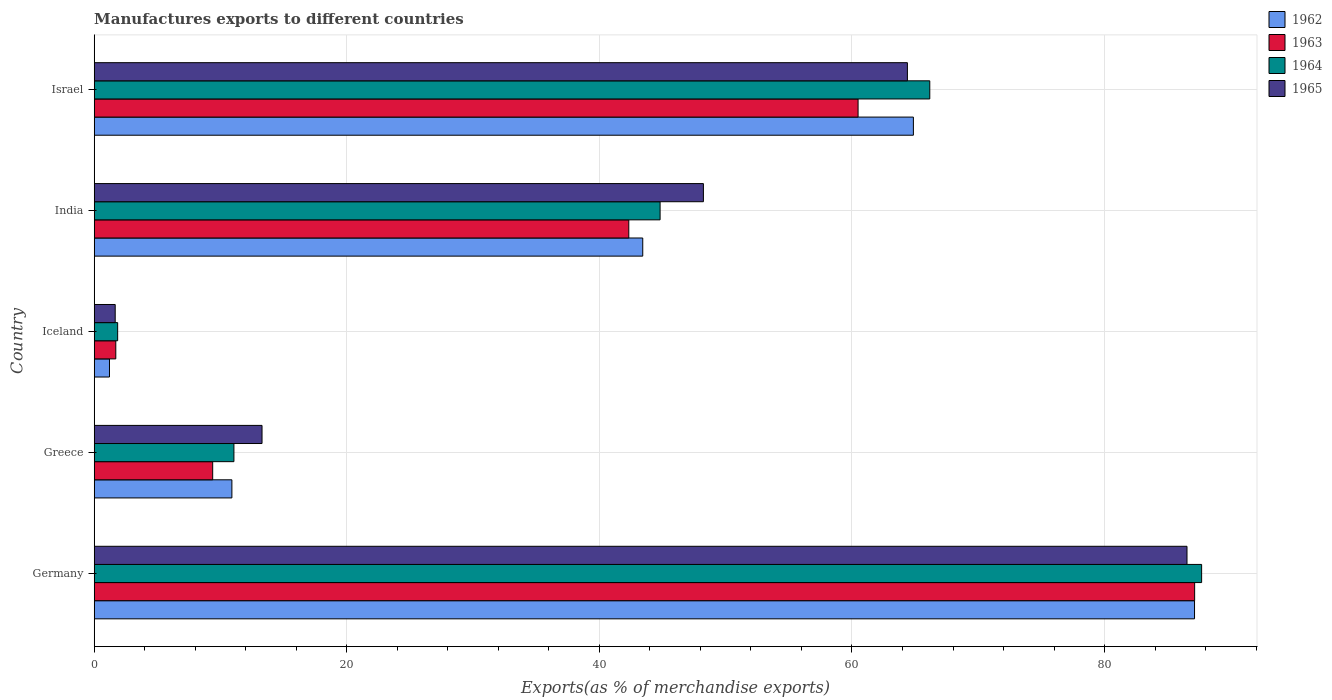How many bars are there on the 4th tick from the top?
Make the answer very short. 4. What is the label of the 4th group of bars from the top?
Your response must be concise. Greece. What is the percentage of exports to different countries in 1962 in Germany?
Your response must be concise. 87.12. Across all countries, what is the maximum percentage of exports to different countries in 1963?
Your answer should be very brief. 87.13. Across all countries, what is the minimum percentage of exports to different countries in 1962?
Give a very brief answer. 1.21. In which country was the percentage of exports to different countries in 1964 maximum?
Your answer should be compact. Germany. What is the total percentage of exports to different countries in 1962 in the graph?
Provide a short and direct response. 207.53. What is the difference between the percentage of exports to different countries in 1965 in Germany and that in Israel?
Keep it short and to the point. 22.14. What is the difference between the percentage of exports to different countries in 1965 in India and the percentage of exports to different countries in 1962 in Germany?
Provide a succinct answer. -38.89. What is the average percentage of exports to different countries in 1964 per country?
Offer a very short reply. 42.31. What is the difference between the percentage of exports to different countries in 1965 and percentage of exports to different countries in 1964 in India?
Keep it short and to the point. 3.43. In how many countries, is the percentage of exports to different countries in 1963 greater than 68 %?
Give a very brief answer. 1. What is the ratio of the percentage of exports to different countries in 1963 in Greece to that in Israel?
Your answer should be compact. 0.16. Is the difference between the percentage of exports to different countries in 1965 in Germany and Greece greater than the difference between the percentage of exports to different countries in 1964 in Germany and Greece?
Give a very brief answer. No. What is the difference between the highest and the second highest percentage of exports to different countries in 1965?
Your response must be concise. 22.14. What is the difference between the highest and the lowest percentage of exports to different countries in 1964?
Your answer should be compact. 85.83. In how many countries, is the percentage of exports to different countries in 1963 greater than the average percentage of exports to different countries in 1963 taken over all countries?
Your response must be concise. 3. What does the 2nd bar from the top in India represents?
Provide a succinct answer. 1964. Are all the bars in the graph horizontal?
Give a very brief answer. Yes. What is the difference between two consecutive major ticks on the X-axis?
Provide a short and direct response. 20. Does the graph contain grids?
Offer a terse response. Yes. How are the legend labels stacked?
Give a very brief answer. Vertical. What is the title of the graph?
Provide a succinct answer. Manufactures exports to different countries. What is the label or title of the X-axis?
Offer a very short reply. Exports(as % of merchandise exports). What is the label or title of the Y-axis?
Your answer should be compact. Country. What is the Exports(as % of merchandise exports) in 1962 in Germany?
Your response must be concise. 87.12. What is the Exports(as % of merchandise exports) of 1963 in Germany?
Your answer should be compact. 87.13. What is the Exports(as % of merchandise exports) in 1964 in Germany?
Your response must be concise. 87.69. What is the Exports(as % of merchandise exports) in 1965 in Germany?
Your answer should be compact. 86.53. What is the Exports(as % of merchandise exports) in 1962 in Greece?
Your response must be concise. 10.9. What is the Exports(as % of merchandise exports) of 1963 in Greece?
Provide a succinct answer. 9.38. What is the Exports(as % of merchandise exports) in 1964 in Greece?
Make the answer very short. 11.06. What is the Exports(as % of merchandise exports) of 1965 in Greece?
Make the answer very short. 13.29. What is the Exports(as % of merchandise exports) of 1962 in Iceland?
Offer a very short reply. 1.21. What is the Exports(as % of merchandise exports) in 1963 in Iceland?
Offer a terse response. 1.71. What is the Exports(as % of merchandise exports) in 1964 in Iceland?
Make the answer very short. 1.86. What is the Exports(as % of merchandise exports) in 1965 in Iceland?
Your response must be concise. 1.66. What is the Exports(as % of merchandise exports) of 1962 in India?
Your response must be concise. 43.43. What is the Exports(as % of merchandise exports) of 1963 in India?
Provide a short and direct response. 42.33. What is the Exports(as % of merchandise exports) of 1964 in India?
Provide a short and direct response. 44.81. What is the Exports(as % of merchandise exports) in 1965 in India?
Offer a terse response. 48.24. What is the Exports(as % of merchandise exports) of 1962 in Israel?
Offer a very short reply. 64.86. What is the Exports(as % of merchandise exports) of 1963 in Israel?
Your response must be concise. 60.48. What is the Exports(as % of merchandise exports) of 1964 in Israel?
Make the answer very short. 66.16. What is the Exports(as % of merchandise exports) of 1965 in Israel?
Keep it short and to the point. 64.39. Across all countries, what is the maximum Exports(as % of merchandise exports) of 1962?
Your answer should be very brief. 87.12. Across all countries, what is the maximum Exports(as % of merchandise exports) of 1963?
Offer a terse response. 87.13. Across all countries, what is the maximum Exports(as % of merchandise exports) in 1964?
Your response must be concise. 87.69. Across all countries, what is the maximum Exports(as % of merchandise exports) of 1965?
Your answer should be very brief. 86.53. Across all countries, what is the minimum Exports(as % of merchandise exports) of 1962?
Offer a terse response. 1.21. Across all countries, what is the minimum Exports(as % of merchandise exports) of 1963?
Offer a terse response. 1.71. Across all countries, what is the minimum Exports(as % of merchandise exports) of 1964?
Provide a short and direct response. 1.86. Across all countries, what is the minimum Exports(as % of merchandise exports) in 1965?
Your answer should be very brief. 1.66. What is the total Exports(as % of merchandise exports) of 1962 in the graph?
Ensure brevity in your answer.  207.53. What is the total Exports(as % of merchandise exports) in 1963 in the graph?
Your answer should be very brief. 201.04. What is the total Exports(as % of merchandise exports) in 1964 in the graph?
Keep it short and to the point. 211.57. What is the total Exports(as % of merchandise exports) of 1965 in the graph?
Provide a succinct answer. 214.11. What is the difference between the Exports(as % of merchandise exports) of 1962 in Germany and that in Greece?
Keep it short and to the point. 76.22. What is the difference between the Exports(as % of merchandise exports) of 1963 in Germany and that in Greece?
Offer a very short reply. 77.75. What is the difference between the Exports(as % of merchandise exports) in 1964 in Germany and that in Greece?
Your response must be concise. 76.62. What is the difference between the Exports(as % of merchandise exports) of 1965 in Germany and that in Greece?
Offer a very short reply. 73.24. What is the difference between the Exports(as % of merchandise exports) of 1962 in Germany and that in Iceland?
Provide a short and direct response. 85.91. What is the difference between the Exports(as % of merchandise exports) of 1963 in Germany and that in Iceland?
Make the answer very short. 85.42. What is the difference between the Exports(as % of merchandise exports) of 1964 in Germany and that in Iceland?
Your response must be concise. 85.83. What is the difference between the Exports(as % of merchandise exports) in 1965 in Germany and that in Iceland?
Make the answer very short. 84.86. What is the difference between the Exports(as % of merchandise exports) in 1962 in Germany and that in India?
Keep it short and to the point. 43.69. What is the difference between the Exports(as % of merchandise exports) in 1963 in Germany and that in India?
Offer a very short reply. 44.8. What is the difference between the Exports(as % of merchandise exports) in 1964 in Germany and that in India?
Offer a terse response. 42.88. What is the difference between the Exports(as % of merchandise exports) in 1965 in Germany and that in India?
Provide a short and direct response. 38.29. What is the difference between the Exports(as % of merchandise exports) of 1962 in Germany and that in Israel?
Provide a short and direct response. 22.26. What is the difference between the Exports(as % of merchandise exports) in 1963 in Germany and that in Israel?
Offer a very short reply. 26.65. What is the difference between the Exports(as % of merchandise exports) in 1964 in Germany and that in Israel?
Provide a short and direct response. 21.52. What is the difference between the Exports(as % of merchandise exports) of 1965 in Germany and that in Israel?
Ensure brevity in your answer.  22.14. What is the difference between the Exports(as % of merchandise exports) in 1962 in Greece and that in Iceland?
Offer a terse response. 9.69. What is the difference between the Exports(as % of merchandise exports) in 1963 in Greece and that in Iceland?
Offer a terse response. 7.67. What is the difference between the Exports(as % of merchandise exports) of 1964 in Greece and that in Iceland?
Your response must be concise. 9.21. What is the difference between the Exports(as % of merchandise exports) of 1965 in Greece and that in Iceland?
Offer a very short reply. 11.63. What is the difference between the Exports(as % of merchandise exports) in 1962 in Greece and that in India?
Offer a terse response. -32.53. What is the difference between the Exports(as % of merchandise exports) in 1963 in Greece and that in India?
Provide a succinct answer. -32.95. What is the difference between the Exports(as % of merchandise exports) in 1964 in Greece and that in India?
Provide a succinct answer. -33.74. What is the difference between the Exports(as % of merchandise exports) in 1965 in Greece and that in India?
Give a very brief answer. -34.95. What is the difference between the Exports(as % of merchandise exports) of 1962 in Greece and that in Israel?
Provide a short and direct response. -53.96. What is the difference between the Exports(as % of merchandise exports) of 1963 in Greece and that in Israel?
Offer a terse response. -51.1. What is the difference between the Exports(as % of merchandise exports) in 1964 in Greece and that in Israel?
Your answer should be compact. -55.1. What is the difference between the Exports(as % of merchandise exports) in 1965 in Greece and that in Israel?
Make the answer very short. -51.1. What is the difference between the Exports(as % of merchandise exports) of 1962 in Iceland and that in India?
Keep it short and to the point. -42.22. What is the difference between the Exports(as % of merchandise exports) in 1963 in Iceland and that in India?
Offer a terse response. -40.62. What is the difference between the Exports(as % of merchandise exports) of 1964 in Iceland and that in India?
Provide a succinct answer. -42.95. What is the difference between the Exports(as % of merchandise exports) in 1965 in Iceland and that in India?
Give a very brief answer. -46.57. What is the difference between the Exports(as % of merchandise exports) of 1962 in Iceland and that in Israel?
Offer a very short reply. -63.65. What is the difference between the Exports(as % of merchandise exports) in 1963 in Iceland and that in Israel?
Keep it short and to the point. -58.77. What is the difference between the Exports(as % of merchandise exports) of 1964 in Iceland and that in Israel?
Your answer should be very brief. -64.3. What is the difference between the Exports(as % of merchandise exports) in 1965 in Iceland and that in Israel?
Offer a very short reply. -62.73. What is the difference between the Exports(as % of merchandise exports) in 1962 in India and that in Israel?
Give a very brief answer. -21.43. What is the difference between the Exports(as % of merchandise exports) in 1963 in India and that in Israel?
Provide a succinct answer. -18.15. What is the difference between the Exports(as % of merchandise exports) of 1964 in India and that in Israel?
Your answer should be compact. -21.35. What is the difference between the Exports(as % of merchandise exports) in 1965 in India and that in Israel?
Give a very brief answer. -16.15. What is the difference between the Exports(as % of merchandise exports) of 1962 in Germany and the Exports(as % of merchandise exports) of 1963 in Greece?
Your response must be concise. 77.74. What is the difference between the Exports(as % of merchandise exports) of 1962 in Germany and the Exports(as % of merchandise exports) of 1964 in Greece?
Make the answer very short. 76.06. What is the difference between the Exports(as % of merchandise exports) in 1962 in Germany and the Exports(as % of merchandise exports) in 1965 in Greece?
Ensure brevity in your answer.  73.84. What is the difference between the Exports(as % of merchandise exports) of 1963 in Germany and the Exports(as % of merchandise exports) of 1964 in Greece?
Provide a succinct answer. 76.07. What is the difference between the Exports(as % of merchandise exports) in 1963 in Germany and the Exports(as % of merchandise exports) in 1965 in Greece?
Your answer should be compact. 73.84. What is the difference between the Exports(as % of merchandise exports) of 1964 in Germany and the Exports(as % of merchandise exports) of 1965 in Greece?
Ensure brevity in your answer.  74.4. What is the difference between the Exports(as % of merchandise exports) in 1962 in Germany and the Exports(as % of merchandise exports) in 1963 in Iceland?
Your response must be concise. 85.41. What is the difference between the Exports(as % of merchandise exports) of 1962 in Germany and the Exports(as % of merchandise exports) of 1964 in Iceland?
Offer a very short reply. 85.27. What is the difference between the Exports(as % of merchandise exports) in 1962 in Germany and the Exports(as % of merchandise exports) in 1965 in Iceland?
Offer a very short reply. 85.46. What is the difference between the Exports(as % of merchandise exports) of 1963 in Germany and the Exports(as % of merchandise exports) of 1964 in Iceland?
Your answer should be very brief. 85.28. What is the difference between the Exports(as % of merchandise exports) of 1963 in Germany and the Exports(as % of merchandise exports) of 1965 in Iceland?
Your response must be concise. 85.47. What is the difference between the Exports(as % of merchandise exports) of 1964 in Germany and the Exports(as % of merchandise exports) of 1965 in Iceland?
Keep it short and to the point. 86.02. What is the difference between the Exports(as % of merchandise exports) in 1962 in Germany and the Exports(as % of merchandise exports) in 1963 in India?
Your answer should be very brief. 44.8. What is the difference between the Exports(as % of merchandise exports) in 1962 in Germany and the Exports(as % of merchandise exports) in 1964 in India?
Ensure brevity in your answer.  42.32. What is the difference between the Exports(as % of merchandise exports) in 1962 in Germany and the Exports(as % of merchandise exports) in 1965 in India?
Provide a short and direct response. 38.89. What is the difference between the Exports(as % of merchandise exports) in 1963 in Germany and the Exports(as % of merchandise exports) in 1964 in India?
Keep it short and to the point. 42.33. What is the difference between the Exports(as % of merchandise exports) of 1963 in Germany and the Exports(as % of merchandise exports) of 1965 in India?
Your answer should be compact. 38.9. What is the difference between the Exports(as % of merchandise exports) of 1964 in Germany and the Exports(as % of merchandise exports) of 1965 in India?
Offer a terse response. 39.45. What is the difference between the Exports(as % of merchandise exports) in 1962 in Germany and the Exports(as % of merchandise exports) in 1963 in Israel?
Make the answer very short. 26.64. What is the difference between the Exports(as % of merchandise exports) in 1962 in Germany and the Exports(as % of merchandise exports) in 1964 in Israel?
Give a very brief answer. 20.96. What is the difference between the Exports(as % of merchandise exports) of 1962 in Germany and the Exports(as % of merchandise exports) of 1965 in Israel?
Offer a terse response. 22.73. What is the difference between the Exports(as % of merchandise exports) in 1963 in Germany and the Exports(as % of merchandise exports) in 1964 in Israel?
Provide a succinct answer. 20.97. What is the difference between the Exports(as % of merchandise exports) of 1963 in Germany and the Exports(as % of merchandise exports) of 1965 in Israel?
Provide a short and direct response. 22.74. What is the difference between the Exports(as % of merchandise exports) in 1964 in Germany and the Exports(as % of merchandise exports) in 1965 in Israel?
Provide a short and direct response. 23.3. What is the difference between the Exports(as % of merchandise exports) of 1962 in Greece and the Exports(as % of merchandise exports) of 1963 in Iceland?
Offer a terse response. 9.19. What is the difference between the Exports(as % of merchandise exports) of 1962 in Greece and the Exports(as % of merchandise exports) of 1964 in Iceland?
Give a very brief answer. 9.05. What is the difference between the Exports(as % of merchandise exports) of 1962 in Greece and the Exports(as % of merchandise exports) of 1965 in Iceland?
Give a very brief answer. 9.24. What is the difference between the Exports(as % of merchandise exports) of 1963 in Greece and the Exports(as % of merchandise exports) of 1964 in Iceland?
Your answer should be compact. 7.52. What is the difference between the Exports(as % of merchandise exports) in 1963 in Greece and the Exports(as % of merchandise exports) in 1965 in Iceland?
Keep it short and to the point. 7.72. What is the difference between the Exports(as % of merchandise exports) of 1964 in Greece and the Exports(as % of merchandise exports) of 1965 in Iceland?
Provide a short and direct response. 9.4. What is the difference between the Exports(as % of merchandise exports) in 1962 in Greece and the Exports(as % of merchandise exports) in 1963 in India?
Provide a succinct answer. -31.43. What is the difference between the Exports(as % of merchandise exports) of 1962 in Greece and the Exports(as % of merchandise exports) of 1964 in India?
Offer a very short reply. -33.91. What is the difference between the Exports(as % of merchandise exports) in 1962 in Greece and the Exports(as % of merchandise exports) in 1965 in India?
Make the answer very short. -37.33. What is the difference between the Exports(as % of merchandise exports) in 1963 in Greece and the Exports(as % of merchandise exports) in 1964 in India?
Your response must be concise. -35.43. What is the difference between the Exports(as % of merchandise exports) of 1963 in Greece and the Exports(as % of merchandise exports) of 1965 in India?
Provide a succinct answer. -38.86. What is the difference between the Exports(as % of merchandise exports) in 1964 in Greece and the Exports(as % of merchandise exports) in 1965 in India?
Provide a succinct answer. -37.17. What is the difference between the Exports(as % of merchandise exports) in 1962 in Greece and the Exports(as % of merchandise exports) in 1963 in Israel?
Make the answer very short. -49.58. What is the difference between the Exports(as % of merchandise exports) of 1962 in Greece and the Exports(as % of merchandise exports) of 1964 in Israel?
Make the answer very short. -55.26. What is the difference between the Exports(as % of merchandise exports) of 1962 in Greece and the Exports(as % of merchandise exports) of 1965 in Israel?
Provide a succinct answer. -53.49. What is the difference between the Exports(as % of merchandise exports) of 1963 in Greece and the Exports(as % of merchandise exports) of 1964 in Israel?
Your response must be concise. -56.78. What is the difference between the Exports(as % of merchandise exports) in 1963 in Greece and the Exports(as % of merchandise exports) in 1965 in Israel?
Keep it short and to the point. -55.01. What is the difference between the Exports(as % of merchandise exports) in 1964 in Greece and the Exports(as % of merchandise exports) in 1965 in Israel?
Offer a terse response. -53.33. What is the difference between the Exports(as % of merchandise exports) in 1962 in Iceland and the Exports(as % of merchandise exports) in 1963 in India?
Your response must be concise. -41.12. What is the difference between the Exports(as % of merchandise exports) of 1962 in Iceland and the Exports(as % of merchandise exports) of 1964 in India?
Offer a very short reply. -43.6. What is the difference between the Exports(as % of merchandise exports) of 1962 in Iceland and the Exports(as % of merchandise exports) of 1965 in India?
Provide a short and direct response. -47.03. What is the difference between the Exports(as % of merchandise exports) in 1963 in Iceland and the Exports(as % of merchandise exports) in 1964 in India?
Your answer should be compact. -43.1. What is the difference between the Exports(as % of merchandise exports) in 1963 in Iceland and the Exports(as % of merchandise exports) in 1965 in India?
Make the answer very short. -46.53. What is the difference between the Exports(as % of merchandise exports) of 1964 in Iceland and the Exports(as % of merchandise exports) of 1965 in India?
Ensure brevity in your answer.  -46.38. What is the difference between the Exports(as % of merchandise exports) in 1962 in Iceland and the Exports(as % of merchandise exports) in 1963 in Israel?
Your response must be concise. -59.27. What is the difference between the Exports(as % of merchandise exports) in 1962 in Iceland and the Exports(as % of merchandise exports) in 1964 in Israel?
Offer a terse response. -64.95. What is the difference between the Exports(as % of merchandise exports) of 1962 in Iceland and the Exports(as % of merchandise exports) of 1965 in Israel?
Provide a short and direct response. -63.18. What is the difference between the Exports(as % of merchandise exports) of 1963 in Iceland and the Exports(as % of merchandise exports) of 1964 in Israel?
Offer a very short reply. -64.45. What is the difference between the Exports(as % of merchandise exports) in 1963 in Iceland and the Exports(as % of merchandise exports) in 1965 in Israel?
Your response must be concise. -62.68. What is the difference between the Exports(as % of merchandise exports) of 1964 in Iceland and the Exports(as % of merchandise exports) of 1965 in Israel?
Give a very brief answer. -62.53. What is the difference between the Exports(as % of merchandise exports) in 1962 in India and the Exports(as % of merchandise exports) in 1963 in Israel?
Ensure brevity in your answer.  -17.05. What is the difference between the Exports(as % of merchandise exports) in 1962 in India and the Exports(as % of merchandise exports) in 1964 in Israel?
Offer a terse response. -22.73. What is the difference between the Exports(as % of merchandise exports) in 1962 in India and the Exports(as % of merchandise exports) in 1965 in Israel?
Keep it short and to the point. -20.96. What is the difference between the Exports(as % of merchandise exports) in 1963 in India and the Exports(as % of merchandise exports) in 1964 in Israel?
Give a very brief answer. -23.83. What is the difference between the Exports(as % of merchandise exports) in 1963 in India and the Exports(as % of merchandise exports) in 1965 in Israel?
Ensure brevity in your answer.  -22.06. What is the difference between the Exports(as % of merchandise exports) in 1964 in India and the Exports(as % of merchandise exports) in 1965 in Israel?
Offer a terse response. -19.58. What is the average Exports(as % of merchandise exports) of 1962 per country?
Ensure brevity in your answer.  41.51. What is the average Exports(as % of merchandise exports) of 1963 per country?
Provide a succinct answer. 40.21. What is the average Exports(as % of merchandise exports) of 1964 per country?
Offer a very short reply. 42.31. What is the average Exports(as % of merchandise exports) of 1965 per country?
Your response must be concise. 42.82. What is the difference between the Exports(as % of merchandise exports) in 1962 and Exports(as % of merchandise exports) in 1963 in Germany?
Ensure brevity in your answer.  -0.01. What is the difference between the Exports(as % of merchandise exports) in 1962 and Exports(as % of merchandise exports) in 1964 in Germany?
Make the answer very short. -0.56. What is the difference between the Exports(as % of merchandise exports) in 1962 and Exports(as % of merchandise exports) in 1965 in Germany?
Provide a succinct answer. 0.6. What is the difference between the Exports(as % of merchandise exports) of 1963 and Exports(as % of merchandise exports) of 1964 in Germany?
Keep it short and to the point. -0.55. What is the difference between the Exports(as % of merchandise exports) in 1963 and Exports(as % of merchandise exports) in 1965 in Germany?
Provide a succinct answer. 0.6. What is the difference between the Exports(as % of merchandise exports) of 1964 and Exports(as % of merchandise exports) of 1965 in Germany?
Your response must be concise. 1.16. What is the difference between the Exports(as % of merchandise exports) in 1962 and Exports(as % of merchandise exports) in 1963 in Greece?
Ensure brevity in your answer.  1.52. What is the difference between the Exports(as % of merchandise exports) in 1962 and Exports(as % of merchandise exports) in 1964 in Greece?
Provide a short and direct response. -0.16. What is the difference between the Exports(as % of merchandise exports) of 1962 and Exports(as % of merchandise exports) of 1965 in Greece?
Keep it short and to the point. -2.39. What is the difference between the Exports(as % of merchandise exports) in 1963 and Exports(as % of merchandise exports) in 1964 in Greece?
Offer a terse response. -1.68. What is the difference between the Exports(as % of merchandise exports) in 1963 and Exports(as % of merchandise exports) in 1965 in Greece?
Provide a succinct answer. -3.91. What is the difference between the Exports(as % of merchandise exports) in 1964 and Exports(as % of merchandise exports) in 1965 in Greece?
Keep it short and to the point. -2.23. What is the difference between the Exports(as % of merchandise exports) of 1962 and Exports(as % of merchandise exports) of 1964 in Iceland?
Your response must be concise. -0.65. What is the difference between the Exports(as % of merchandise exports) in 1962 and Exports(as % of merchandise exports) in 1965 in Iceland?
Keep it short and to the point. -0.45. What is the difference between the Exports(as % of merchandise exports) of 1963 and Exports(as % of merchandise exports) of 1964 in Iceland?
Your response must be concise. -0.15. What is the difference between the Exports(as % of merchandise exports) in 1963 and Exports(as % of merchandise exports) in 1965 in Iceland?
Ensure brevity in your answer.  0.05. What is the difference between the Exports(as % of merchandise exports) of 1964 and Exports(as % of merchandise exports) of 1965 in Iceland?
Your answer should be very brief. 0.19. What is the difference between the Exports(as % of merchandise exports) in 1962 and Exports(as % of merchandise exports) in 1963 in India?
Offer a very short reply. 1.11. What is the difference between the Exports(as % of merchandise exports) of 1962 and Exports(as % of merchandise exports) of 1964 in India?
Keep it short and to the point. -1.37. What is the difference between the Exports(as % of merchandise exports) in 1962 and Exports(as % of merchandise exports) in 1965 in India?
Provide a succinct answer. -4.8. What is the difference between the Exports(as % of merchandise exports) of 1963 and Exports(as % of merchandise exports) of 1964 in India?
Ensure brevity in your answer.  -2.48. What is the difference between the Exports(as % of merchandise exports) of 1963 and Exports(as % of merchandise exports) of 1965 in India?
Your response must be concise. -5.91. What is the difference between the Exports(as % of merchandise exports) of 1964 and Exports(as % of merchandise exports) of 1965 in India?
Offer a very short reply. -3.43. What is the difference between the Exports(as % of merchandise exports) of 1962 and Exports(as % of merchandise exports) of 1963 in Israel?
Offer a terse response. 4.38. What is the difference between the Exports(as % of merchandise exports) of 1962 and Exports(as % of merchandise exports) of 1964 in Israel?
Keep it short and to the point. -1.3. What is the difference between the Exports(as % of merchandise exports) in 1962 and Exports(as % of merchandise exports) in 1965 in Israel?
Provide a short and direct response. 0.47. What is the difference between the Exports(as % of merchandise exports) in 1963 and Exports(as % of merchandise exports) in 1964 in Israel?
Make the answer very short. -5.68. What is the difference between the Exports(as % of merchandise exports) of 1963 and Exports(as % of merchandise exports) of 1965 in Israel?
Keep it short and to the point. -3.91. What is the difference between the Exports(as % of merchandise exports) of 1964 and Exports(as % of merchandise exports) of 1965 in Israel?
Provide a succinct answer. 1.77. What is the ratio of the Exports(as % of merchandise exports) in 1962 in Germany to that in Greece?
Give a very brief answer. 7.99. What is the ratio of the Exports(as % of merchandise exports) of 1963 in Germany to that in Greece?
Your answer should be compact. 9.29. What is the ratio of the Exports(as % of merchandise exports) in 1964 in Germany to that in Greece?
Your response must be concise. 7.93. What is the ratio of the Exports(as % of merchandise exports) in 1965 in Germany to that in Greece?
Give a very brief answer. 6.51. What is the ratio of the Exports(as % of merchandise exports) of 1962 in Germany to that in Iceland?
Give a very brief answer. 71.98. What is the ratio of the Exports(as % of merchandise exports) of 1963 in Germany to that in Iceland?
Your response must be concise. 50.94. What is the ratio of the Exports(as % of merchandise exports) in 1964 in Germany to that in Iceland?
Keep it short and to the point. 47.21. What is the ratio of the Exports(as % of merchandise exports) in 1965 in Germany to that in Iceland?
Provide a short and direct response. 52.03. What is the ratio of the Exports(as % of merchandise exports) in 1962 in Germany to that in India?
Ensure brevity in your answer.  2.01. What is the ratio of the Exports(as % of merchandise exports) of 1963 in Germany to that in India?
Offer a very short reply. 2.06. What is the ratio of the Exports(as % of merchandise exports) of 1964 in Germany to that in India?
Ensure brevity in your answer.  1.96. What is the ratio of the Exports(as % of merchandise exports) of 1965 in Germany to that in India?
Provide a short and direct response. 1.79. What is the ratio of the Exports(as % of merchandise exports) in 1962 in Germany to that in Israel?
Make the answer very short. 1.34. What is the ratio of the Exports(as % of merchandise exports) of 1963 in Germany to that in Israel?
Keep it short and to the point. 1.44. What is the ratio of the Exports(as % of merchandise exports) in 1964 in Germany to that in Israel?
Ensure brevity in your answer.  1.33. What is the ratio of the Exports(as % of merchandise exports) in 1965 in Germany to that in Israel?
Ensure brevity in your answer.  1.34. What is the ratio of the Exports(as % of merchandise exports) of 1962 in Greece to that in Iceland?
Provide a short and direct response. 9.01. What is the ratio of the Exports(as % of merchandise exports) in 1963 in Greece to that in Iceland?
Your answer should be very brief. 5.49. What is the ratio of the Exports(as % of merchandise exports) of 1964 in Greece to that in Iceland?
Give a very brief answer. 5.96. What is the ratio of the Exports(as % of merchandise exports) of 1965 in Greece to that in Iceland?
Your response must be concise. 7.99. What is the ratio of the Exports(as % of merchandise exports) of 1962 in Greece to that in India?
Your answer should be very brief. 0.25. What is the ratio of the Exports(as % of merchandise exports) in 1963 in Greece to that in India?
Make the answer very short. 0.22. What is the ratio of the Exports(as % of merchandise exports) of 1964 in Greece to that in India?
Offer a very short reply. 0.25. What is the ratio of the Exports(as % of merchandise exports) in 1965 in Greece to that in India?
Ensure brevity in your answer.  0.28. What is the ratio of the Exports(as % of merchandise exports) in 1962 in Greece to that in Israel?
Your answer should be compact. 0.17. What is the ratio of the Exports(as % of merchandise exports) of 1963 in Greece to that in Israel?
Ensure brevity in your answer.  0.16. What is the ratio of the Exports(as % of merchandise exports) in 1964 in Greece to that in Israel?
Provide a short and direct response. 0.17. What is the ratio of the Exports(as % of merchandise exports) in 1965 in Greece to that in Israel?
Your answer should be very brief. 0.21. What is the ratio of the Exports(as % of merchandise exports) in 1962 in Iceland to that in India?
Offer a terse response. 0.03. What is the ratio of the Exports(as % of merchandise exports) of 1963 in Iceland to that in India?
Give a very brief answer. 0.04. What is the ratio of the Exports(as % of merchandise exports) in 1964 in Iceland to that in India?
Provide a short and direct response. 0.04. What is the ratio of the Exports(as % of merchandise exports) of 1965 in Iceland to that in India?
Your answer should be compact. 0.03. What is the ratio of the Exports(as % of merchandise exports) of 1962 in Iceland to that in Israel?
Provide a succinct answer. 0.02. What is the ratio of the Exports(as % of merchandise exports) of 1963 in Iceland to that in Israel?
Keep it short and to the point. 0.03. What is the ratio of the Exports(as % of merchandise exports) of 1964 in Iceland to that in Israel?
Offer a terse response. 0.03. What is the ratio of the Exports(as % of merchandise exports) in 1965 in Iceland to that in Israel?
Provide a short and direct response. 0.03. What is the ratio of the Exports(as % of merchandise exports) in 1962 in India to that in Israel?
Your answer should be very brief. 0.67. What is the ratio of the Exports(as % of merchandise exports) of 1963 in India to that in Israel?
Provide a short and direct response. 0.7. What is the ratio of the Exports(as % of merchandise exports) in 1964 in India to that in Israel?
Offer a terse response. 0.68. What is the ratio of the Exports(as % of merchandise exports) in 1965 in India to that in Israel?
Provide a succinct answer. 0.75. What is the difference between the highest and the second highest Exports(as % of merchandise exports) of 1962?
Make the answer very short. 22.26. What is the difference between the highest and the second highest Exports(as % of merchandise exports) of 1963?
Keep it short and to the point. 26.65. What is the difference between the highest and the second highest Exports(as % of merchandise exports) in 1964?
Give a very brief answer. 21.52. What is the difference between the highest and the second highest Exports(as % of merchandise exports) of 1965?
Your answer should be very brief. 22.14. What is the difference between the highest and the lowest Exports(as % of merchandise exports) of 1962?
Ensure brevity in your answer.  85.91. What is the difference between the highest and the lowest Exports(as % of merchandise exports) in 1963?
Your response must be concise. 85.42. What is the difference between the highest and the lowest Exports(as % of merchandise exports) in 1964?
Offer a very short reply. 85.83. What is the difference between the highest and the lowest Exports(as % of merchandise exports) of 1965?
Make the answer very short. 84.86. 